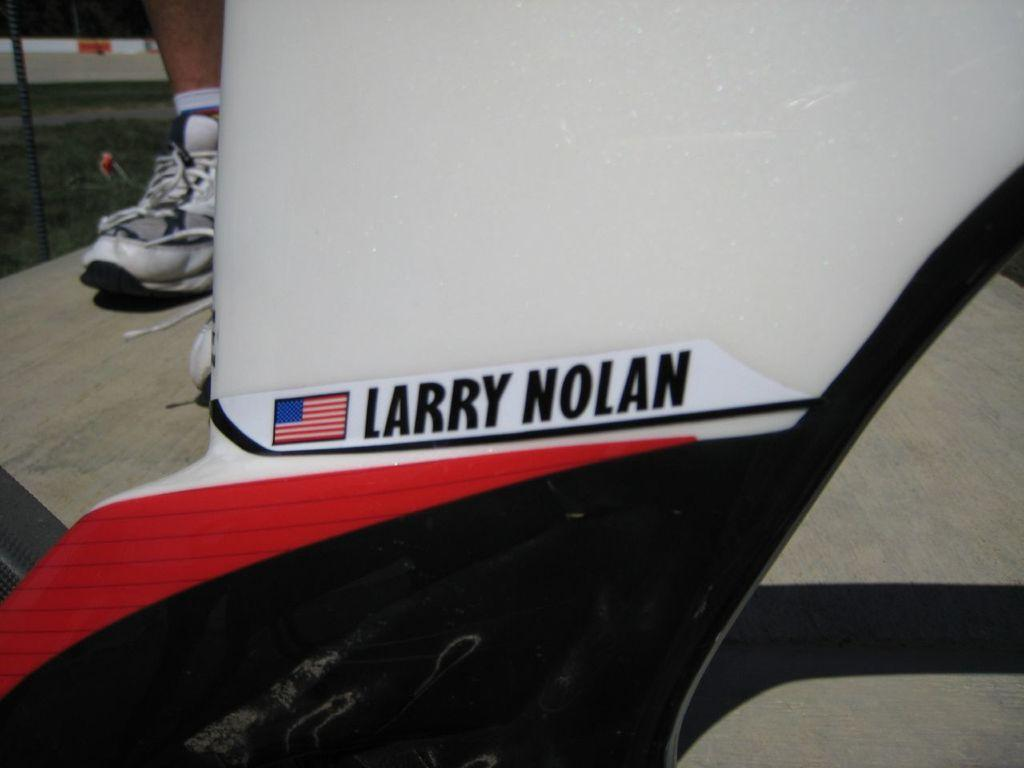What can be seen in the image that has text on it? There is an object with text in the image. What type of symbol or emblem is present in the image? There is a flag in the image. What part of a person's body can be seen in the image? A person's leg is visible in the image. What is covering the person's foot in the image? The person's leg has a shoe on it. What type of animal can be seen playing cards in the image? There is no animal or card game present in the image. Where is the hall located in the image? There is no hall mentioned or depicted in the image. 